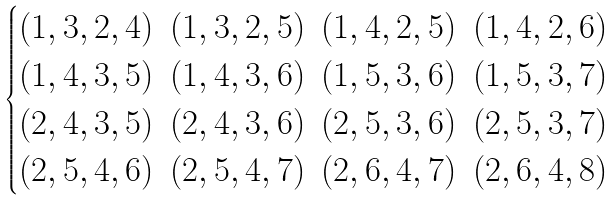Convert formula to latex. <formula><loc_0><loc_0><loc_500><loc_500>\begin{cases} \begin{matrix} ( 1 , 3 , 2 , 4 ) & ( 1 , 3 , 2 , 5 ) & ( 1 , 4 , 2 , 5 ) & ( 1 , 4 , 2 , 6 ) \\ ( 1 , 4 , 3 , 5 ) & ( 1 , 4 , 3 , 6 ) & ( 1 , 5 , 3 , 6 ) & ( 1 , 5 , 3 , 7 ) \\ ( 2 , 4 , 3 , 5 ) & ( 2 , 4 , 3 , 6 ) & ( 2 , 5 , 3 , 6 ) & ( 2 , 5 , 3 , 7 ) \\ ( 2 , 5 , 4 , 6 ) & ( 2 , 5 , 4 , 7 ) & ( 2 , 6 , 4 , 7 ) & ( 2 , 6 , 4 , 8 ) \\ \end{matrix} \end{cases}</formula> 